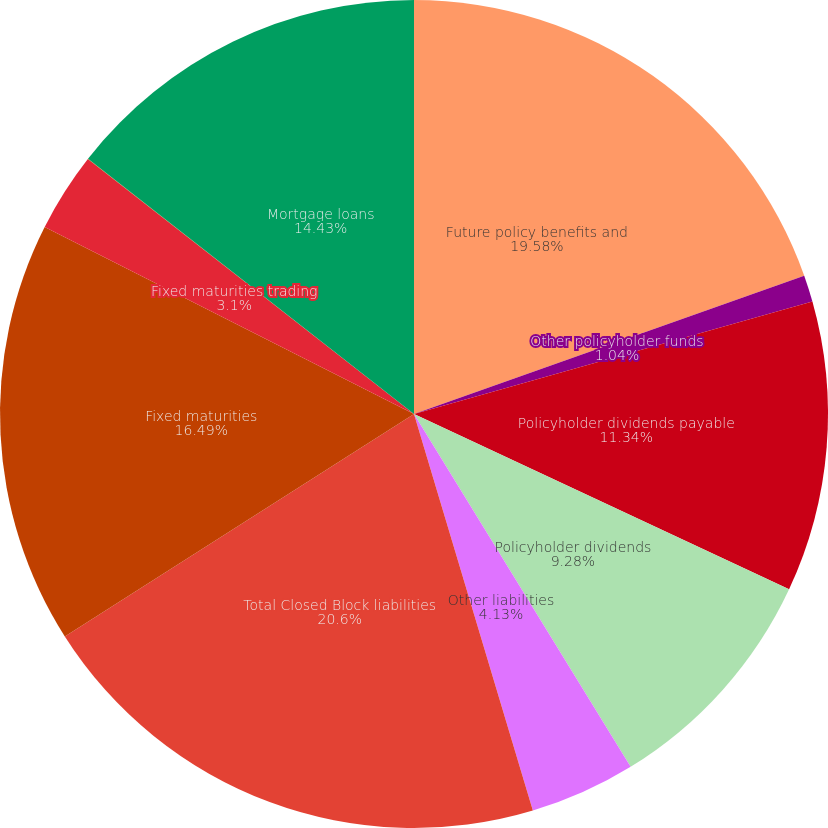Convert chart. <chart><loc_0><loc_0><loc_500><loc_500><pie_chart><fcel>Future policy benefits and<fcel>Other policyholder funds<fcel>Policyholder dividends payable<fcel>Policyholder dividends<fcel>Other liabilities<fcel>Total Closed Block liabilities<fcel>Fixed maturities<fcel>Fixed maturities trading<fcel>Equity securities<fcel>Mortgage loans<nl><fcel>19.58%<fcel>1.04%<fcel>11.34%<fcel>9.28%<fcel>4.13%<fcel>20.61%<fcel>16.49%<fcel>3.1%<fcel>0.01%<fcel>14.43%<nl></chart> 